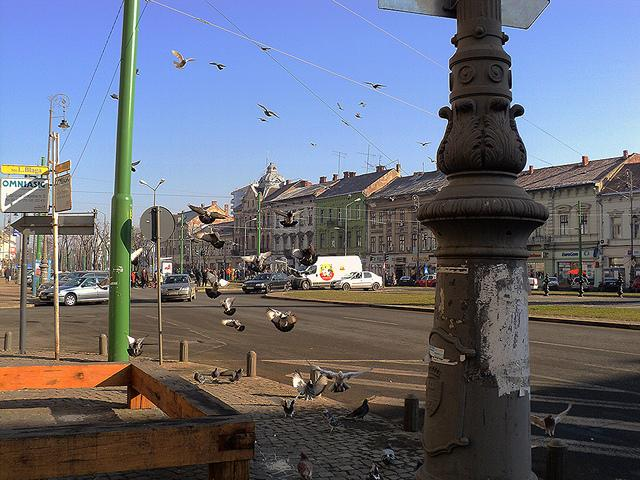Those birds are related to what other type of bird? pigeons 